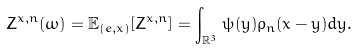Convert formula to latex. <formula><loc_0><loc_0><loc_500><loc_500>Z ^ { x , n } ( \omega ) = \mathbb { E } _ { ( e , x ) } [ Z ^ { x , n } ] = \int _ { \mathbb { R } ^ { 3 } } \psi ( y ) \rho _ { n } ( x - y ) d y .</formula> 